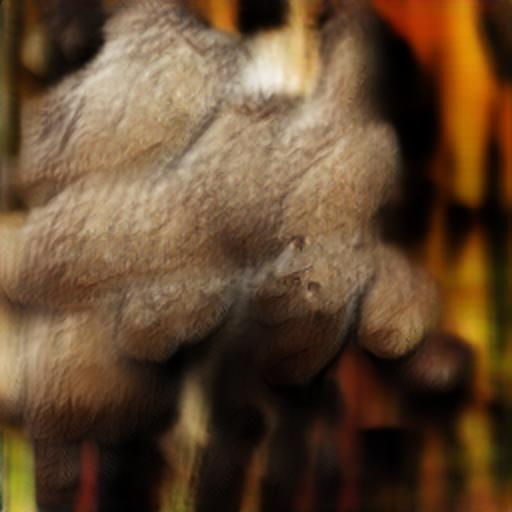Could this image be effectively used in an artistic context? Absolutely, the abstract nature and the warm color palette make it suitable for an artistic context. It could serve as a background, an inspiration piece for an installation or be used to evoke certain emotions in the viewer. 